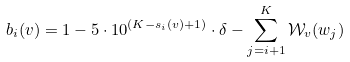Convert formula to latex. <formula><loc_0><loc_0><loc_500><loc_500>b _ { i } ( v ) = 1 - 5 \cdot 1 0 ^ { ( K - s _ { i } ( v ) + 1 ) } \cdot \delta - \sum _ { j = i + 1 } ^ { K } \mathcal { W } _ { v } ( w _ { j } )</formula> 